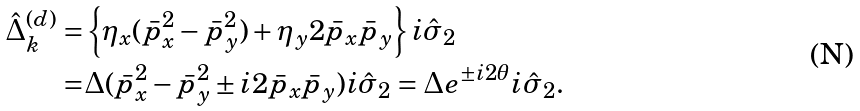Convert formula to latex. <formula><loc_0><loc_0><loc_500><loc_500>\hat { \Delta } _ { k } ^ { ( d ) } = & \left \{ \eta _ { x } ( \bar { p } _ { x } ^ { 2 } - \bar { p } _ { y } ^ { 2 } ) + \eta _ { y } 2 \bar { p } _ { x } \bar { p } _ { y } \right \} i \hat { \sigma } _ { 2 } \\ = & \Delta ( \bar { p } _ { x } ^ { 2 } - \bar { p } _ { y } ^ { 2 } \pm i 2 \bar { p } _ { x } \bar { p } _ { y } ) i \hat { \sigma } _ { 2 } = \Delta e ^ { \pm i 2 \theta } i \hat { \sigma } _ { 2 } .</formula> 